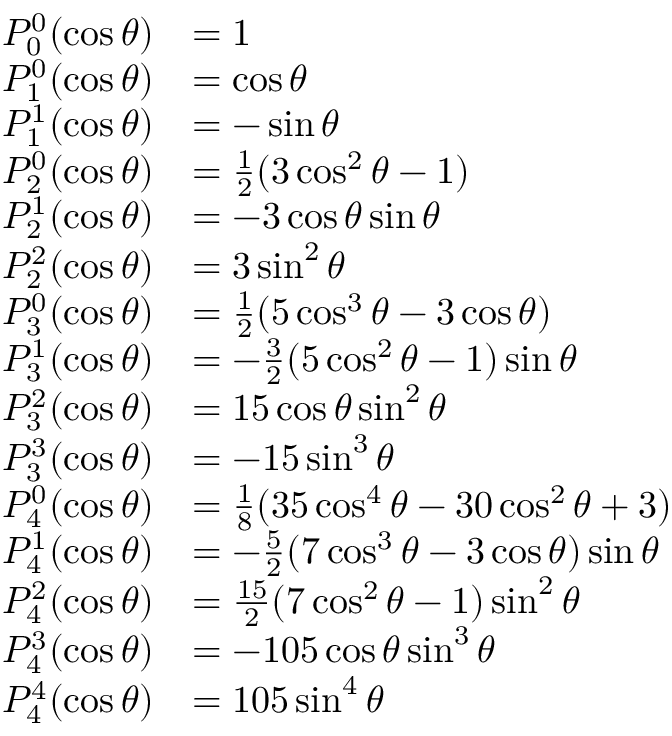<formula> <loc_0><loc_0><loc_500><loc_500>{ \begin{array} { r l } { P _ { 0 } ^ { 0 } ( \cos \theta ) } & { = 1 } \\ { P _ { 1 } ^ { 0 } ( \cos \theta ) } & { = \cos \theta } \\ { P _ { 1 } ^ { 1 } ( \cos \theta ) } & { = - \sin \theta } \\ { P _ { 2 } ^ { 0 } ( \cos \theta ) } & { = { \frac { 1 } { 2 } } ( 3 \cos ^ { 2 } \theta - 1 ) } \\ { P _ { 2 } ^ { 1 } ( \cos \theta ) } & { = - 3 \cos \theta \sin \theta } \\ { P _ { 2 } ^ { 2 } ( \cos \theta ) } & { = 3 \sin ^ { 2 } \theta } \\ { P _ { 3 } ^ { 0 } ( \cos \theta ) } & { = { \frac { 1 } { 2 } } ( 5 \cos ^ { 3 } \theta - 3 \cos \theta ) } \\ { P _ { 3 } ^ { 1 } ( \cos \theta ) } & { = - { \frac { 3 } { 2 } } ( 5 \cos ^ { 2 } \theta - 1 ) \sin \theta } \\ { P _ { 3 } ^ { 2 } ( \cos \theta ) } & { = 1 5 \cos \theta \sin ^ { 2 } \theta } \\ { P _ { 3 } ^ { 3 } ( \cos \theta ) } & { = - 1 5 \sin ^ { 3 } \theta } \\ { P _ { 4 } ^ { 0 } ( \cos \theta ) } & { = { \frac { 1 } { 8 } } ( 3 5 \cos ^ { 4 } \theta - 3 0 \cos ^ { 2 } \theta + 3 ) } \\ { P _ { 4 } ^ { 1 } ( \cos \theta ) } & { = - { \frac { 5 } { 2 } } ( 7 \cos ^ { 3 } \theta - 3 \cos \theta ) \sin \theta } \\ { P _ { 4 } ^ { 2 } ( \cos \theta ) } & { = { \frac { 1 5 } { 2 } } ( 7 \cos ^ { 2 } \theta - 1 ) \sin ^ { 2 } \theta } \\ { P _ { 4 } ^ { 3 } ( \cos \theta ) } & { = - 1 0 5 \cos \theta \sin ^ { 3 } \theta } \\ { P _ { 4 } ^ { 4 } ( \cos \theta ) } & { = 1 0 5 \sin ^ { 4 } \theta } \end{array} }</formula> 